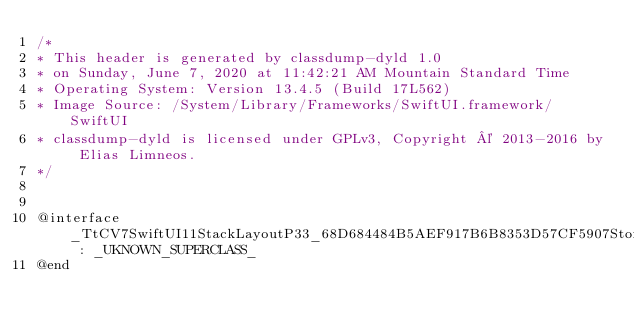<code> <loc_0><loc_0><loc_500><loc_500><_C_>/*
* This header is generated by classdump-dyld 1.0
* on Sunday, June 7, 2020 at 11:42:21 AM Mountain Standard Time
* Operating System: Version 13.4.5 (Build 17L562)
* Image Source: /System/Library/Frameworks/SwiftUI.framework/SwiftUI
* classdump-dyld is licensed under GPLv3, Copyright © 2013-2016 by Elias Limneos.
*/


@interface _TtCV7SwiftUI11StackLayoutP33_68D684484B5AEF917B6B8353D57CF5907Storage : _UKNOWN_SUPERCLASS_
@end

</code> 